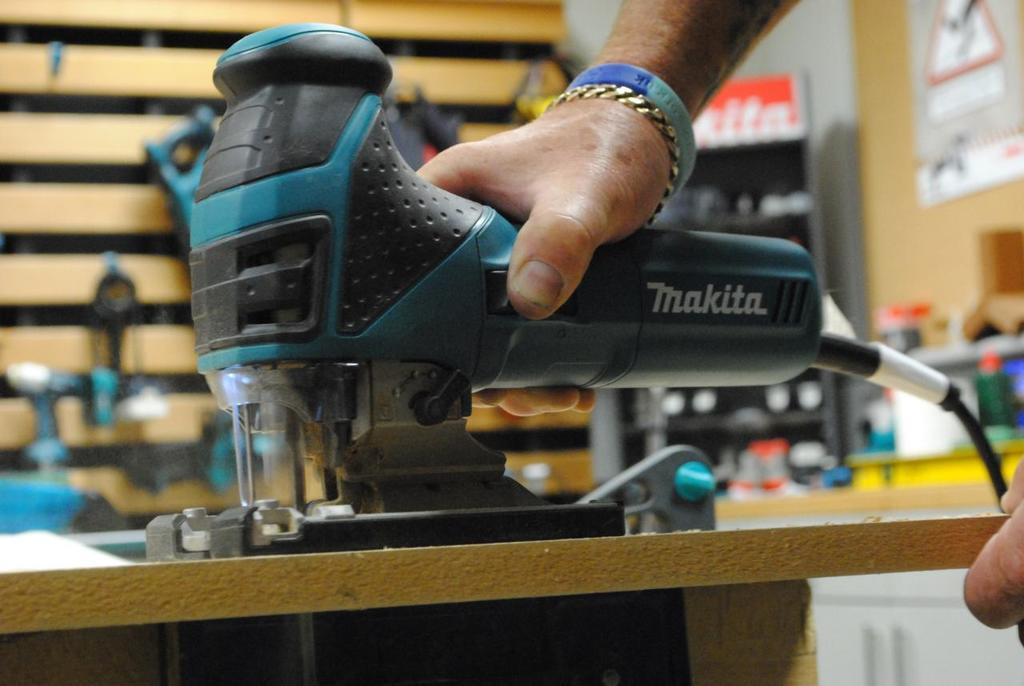Who is present in the image? There is a man in the image. What is the man holding in the image? The man is holding a drilling machine. What can be seen on the wall in the background of the image? There are other equipment on the wall in the background. How would you describe the background of the image? The background of the image is slightly blurred. What type of reward is the man receiving in the image? There is no indication in the image that the man is receiving a reward, so it cannot be determined from the picture. 